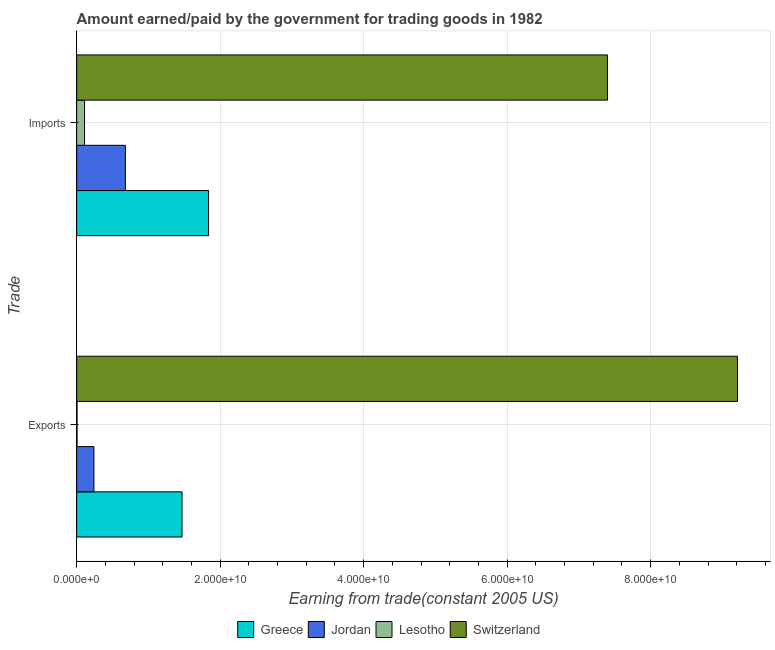How many groups of bars are there?
Give a very brief answer. 2. Are the number of bars on each tick of the Y-axis equal?
Your answer should be very brief. Yes. What is the label of the 1st group of bars from the top?
Make the answer very short. Imports. What is the amount earned from exports in Jordan?
Ensure brevity in your answer.  2.41e+09. Across all countries, what is the maximum amount paid for imports?
Make the answer very short. 7.40e+1. Across all countries, what is the minimum amount earned from exports?
Keep it short and to the point. 5.30e+07. In which country was the amount earned from exports maximum?
Provide a short and direct response. Switzerland. In which country was the amount paid for imports minimum?
Your answer should be very brief. Lesotho. What is the total amount paid for imports in the graph?
Offer a very short reply. 1.00e+11. What is the difference between the amount paid for imports in Lesotho and that in Greece?
Your response must be concise. -1.73e+1. What is the difference between the amount paid for imports in Switzerland and the amount earned from exports in Jordan?
Provide a succinct answer. 7.16e+1. What is the average amount earned from exports per country?
Your response must be concise. 2.73e+1. What is the difference between the amount earned from exports and amount paid for imports in Lesotho?
Your response must be concise. -1.05e+09. In how many countries, is the amount earned from exports greater than 84000000000 US$?
Provide a succinct answer. 1. What is the ratio of the amount paid for imports in Lesotho to that in Greece?
Your response must be concise. 0.06. Is the amount earned from exports in Switzerland less than that in Lesotho?
Your response must be concise. No. What does the 4th bar from the bottom in Imports represents?
Your answer should be compact. Switzerland. Are all the bars in the graph horizontal?
Offer a very short reply. Yes. What is the difference between two consecutive major ticks on the X-axis?
Keep it short and to the point. 2.00e+1. Are the values on the major ticks of X-axis written in scientific E-notation?
Ensure brevity in your answer.  Yes. How many legend labels are there?
Offer a very short reply. 4. What is the title of the graph?
Make the answer very short. Amount earned/paid by the government for trading goods in 1982. What is the label or title of the X-axis?
Offer a terse response. Earning from trade(constant 2005 US). What is the label or title of the Y-axis?
Offer a very short reply. Trade. What is the Earning from trade(constant 2005 US) in Greece in Exports?
Your answer should be very brief. 1.47e+1. What is the Earning from trade(constant 2005 US) of Jordan in Exports?
Keep it short and to the point. 2.41e+09. What is the Earning from trade(constant 2005 US) of Lesotho in Exports?
Your answer should be compact. 5.30e+07. What is the Earning from trade(constant 2005 US) in Switzerland in Exports?
Give a very brief answer. 9.21e+1. What is the Earning from trade(constant 2005 US) of Greece in Imports?
Your response must be concise. 1.84e+1. What is the Earning from trade(constant 2005 US) of Jordan in Imports?
Make the answer very short. 6.79e+09. What is the Earning from trade(constant 2005 US) in Lesotho in Imports?
Give a very brief answer. 1.10e+09. What is the Earning from trade(constant 2005 US) in Switzerland in Imports?
Give a very brief answer. 7.40e+1. Across all Trade, what is the maximum Earning from trade(constant 2005 US) in Greece?
Your response must be concise. 1.84e+1. Across all Trade, what is the maximum Earning from trade(constant 2005 US) in Jordan?
Ensure brevity in your answer.  6.79e+09. Across all Trade, what is the maximum Earning from trade(constant 2005 US) of Lesotho?
Offer a very short reply. 1.10e+09. Across all Trade, what is the maximum Earning from trade(constant 2005 US) of Switzerland?
Provide a short and direct response. 9.21e+1. Across all Trade, what is the minimum Earning from trade(constant 2005 US) of Greece?
Give a very brief answer. 1.47e+1. Across all Trade, what is the minimum Earning from trade(constant 2005 US) of Jordan?
Offer a very short reply. 2.41e+09. Across all Trade, what is the minimum Earning from trade(constant 2005 US) of Lesotho?
Provide a succinct answer. 5.30e+07. Across all Trade, what is the minimum Earning from trade(constant 2005 US) of Switzerland?
Offer a very short reply. 7.40e+1. What is the total Earning from trade(constant 2005 US) in Greece in the graph?
Offer a terse response. 3.31e+1. What is the total Earning from trade(constant 2005 US) in Jordan in the graph?
Provide a succinct answer. 9.20e+09. What is the total Earning from trade(constant 2005 US) of Lesotho in the graph?
Provide a short and direct response. 1.15e+09. What is the total Earning from trade(constant 2005 US) of Switzerland in the graph?
Provide a short and direct response. 1.66e+11. What is the difference between the Earning from trade(constant 2005 US) of Greece in Exports and that in Imports?
Provide a short and direct response. -3.70e+09. What is the difference between the Earning from trade(constant 2005 US) of Jordan in Exports and that in Imports?
Keep it short and to the point. -4.38e+09. What is the difference between the Earning from trade(constant 2005 US) in Lesotho in Exports and that in Imports?
Ensure brevity in your answer.  -1.05e+09. What is the difference between the Earning from trade(constant 2005 US) of Switzerland in Exports and that in Imports?
Your answer should be very brief. 1.81e+1. What is the difference between the Earning from trade(constant 2005 US) of Greece in Exports and the Earning from trade(constant 2005 US) of Jordan in Imports?
Ensure brevity in your answer.  7.89e+09. What is the difference between the Earning from trade(constant 2005 US) in Greece in Exports and the Earning from trade(constant 2005 US) in Lesotho in Imports?
Give a very brief answer. 1.36e+1. What is the difference between the Earning from trade(constant 2005 US) in Greece in Exports and the Earning from trade(constant 2005 US) in Switzerland in Imports?
Offer a terse response. -5.93e+1. What is the difference between the Earning from trade(constant 2005 US) of Jordan in Exports and the Earning from trade(constant 2005 US) of Lesotho in Imports?
Provide a short and direct response. 1.31e+09. What is the difference between the Earning from trade(constant 2005 US) in Jordan in Exports and the Earning from trade(constant 2005 US) in Switzerland in Imports?
Give a very brief answer. -7.16e+1. What is the difference between the Earning from trade(constant 2005 US) in Lesotho in Exports and the Earning from trade(constant 2005 US) in Switzerland in Imports?
Your answer should be very brief. -7.39e+1. What is the average Earning from trade(constant 2005 US) of Greece per Trade?
Your answer should be compact. 1.65e+1. What is the average Earning from trade(constant 2005 US) in Jordan per Trade?
Give a very brief answer. 4.60e+09. What is the average Earning from trade(constant 2005 US) of Lesotho per Trade?
Offer a very short reply. 5.76e+08. What is the average Earning from trade(constant 2005 US) in Switzerland per Trade?
Offer a very short reply. 8.30e+1. What is the difference between the Earning from trade(constant 2005 US) of Greece and Earning from trade(constant 2005 US) of Jordan in Exports?
Your answer should be very brief. 1.23e+1. What is the difference between the Earning from trade(constant 2005 US) in Greece and Earning from trade(constant 2005 US) in Lesotho in Exports?
Offer a very short reply. 1.46e+1. What is the difference between the Earning from trade(constant 2005 US) in Greece and Earning from trade(constant 2005 US) in Switzerland in Exports?
Your answer should be very brief. -7.74e+1. What is the difference between the Earning from trade(constant 2005 US) in Jordan and Earning from trade(constant 2005 US) in Lesotho in Exports?
Provide a succinct answer. 2.35e+09. What is the difference between the Earning from trade(constant 2005 US) in Jordan and Earning from trade(constant 2005 US) in Switzerland in Exports?
Your response must be concise. -8.97e+1. What is the difference between the Earning from trade(constant 2005 US) in Lesotho and Earning from trade(constant 2005 US) in Switzerland in Exports?
Give a very brief answer. -9.20e+1. What is the difference between the Earning from trade(constant 2005 US) of Greece and Earning from trade(constant 2005 US) of Jordan in Imports?
Provide a short and direct response. 1.16e+1. What is the difference between the Earning from trade(constant 2005 US) of Greece and Earning from trade(constant 2005 US) of Lesotho in Imports?
Offer a very short reply. 1.73e+1. What is the difference between the Earning from trade(constant 2005 US) of Greece and Earning from trade(constant 2005 US) of Switzerland in Imports?
Give a very brief answer. -5.56e+1. What is the difference between the Earning from trade(constant 2005 US) of Jordan and Earning from trade(constant 2005 US) of Lesotho in Imports?
Give a very brief answer. 5.69e+09. What is the difference between the Earning from trade(constant 2005 US) in Jordan and Earning from trade(constant 2005 US) in Switzerland in Imports?
Offer a terse response. -6.72e+1. What is the difference between the Earning from trade(constant 2005 US) in Lesotho and Earning from trade(constant 2005 US) in Switzerland in Imports?
Give a very brief answer. -7.29e+1. What is the ratio of the Earning from trade(constant 2005 US) of Greece in Exports to that in Imports?
Your answer should be compact. 0.8. What is the ratio of the Earning from trade(constant 2005 US) in Jordan in Exports to that in Imports?
Give a very brief answer. 0.35. What is the ratio of the Earning from trade(constant 2005 US) of Lesotho in Exports to that in Imports?
Offer a terse response. 0.05. What is the ratio of the Earning from trade(constant 2005 US) in Switzerland in Exports to that in Imports?
Provide a succinct answer. 1.24. What is the difference between the highest and the second highest Earning from trade(constant 2005 US) of Greece?
Ensure brevity in your answer.  3.70e+09. What is the difference between the highest and the second highest Earning from trade(constant 2005 US) of Jordan?
Your response must be concise. 4.38e+09. What is the difference between the highest and the second highest Earning from trade(constant 2005 US) of Lesotho?
Give a very brief answer. 1.05e+09. What is the difference between the highest and the second highest Earning from trade(constant 2005 US) of Switzerland?
Provide a short and direct response. 1.81e+1. What is the difference between the highest and the lowest Earning from trade(constant 2005 US) in Greece?
Ensure brevity in your answer.  3.70e+09. What is the difference between the highest and the lowest Earning from trade(constant 2005 US) of Jordan?
Offer a very short reply. 4.38e+09. What is the difference between the highest and the lowest Earning from trade(constant 2005 US) of Lesotho?
Offer a very short reply. 1.05e+09. What is the difference between the highest and the lowest Earning from trade(constant 2005 US) in Switzerland?
Your answer should be compact. 1.81e+1. 